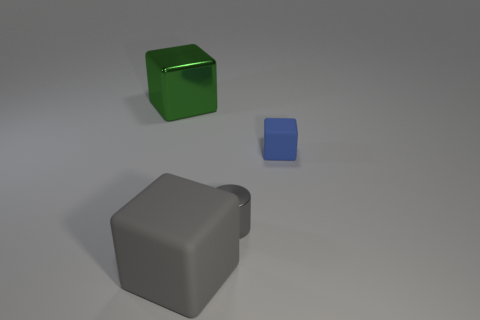There is a shiny cylinder that is the same color as the big matte object; what size is it?
Ensure brevity in your answer.  Small. Are there an equal number of small shiny cylinders behind the large metal block and blue matte cubes left of the gray block?
Keep it short and to the point. Yes. There is a gray block; are there any matte objects behind it?
Ensure brevity in your answer.  Yes. What color is the matte object in front of the tiny cylinder?
Offer a terse response. Gray. What is the material of the block that is to the right of the large object that is in front of the blue matte thing?
Provide a short and direct response. Rubber. Are there fewer gray cubes in front of the tiny gray metal cylinder than things that are to the left of the tiny rubber thing?
Offer a terse response. Yes. What number of blue things are matte blocks or blocks?
Provide a short and direct response. 1. Are there the same number of matte blocks that are left of the large green block and small green matte objects?
Your answer should be compact. Yes. How many things are tiny blue balls or large cubes that are right of the big green block?
Keep it short and to the point. 1. Is the small metal object the same color as the big matte cube?
Your answer should be compact. Yes. 